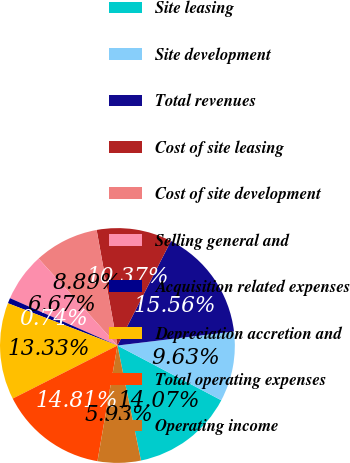<chart> <loc_0><loc_0><loc_500><loc_500><pie_chart><fcel>Site leasing<fcel>Site development<fcel>Total revenues<fcel>Cost of site leasing<fcel>Cost of site development<fcel>Selling general and<fcel>Acquisition related expenses<fcel>Depreciation accretion and<fcel>Total operating expenses<fcel>Operating income<nl><fcel>14.07%<fcel>9.63%<fcel>15.56%<fcel>10.37%<fcel>8.89%<fcel>6.67%<fcel>0.74%<fcel>13.33%<fcel>14.81%<fcel>5.93%<nl></chart> 